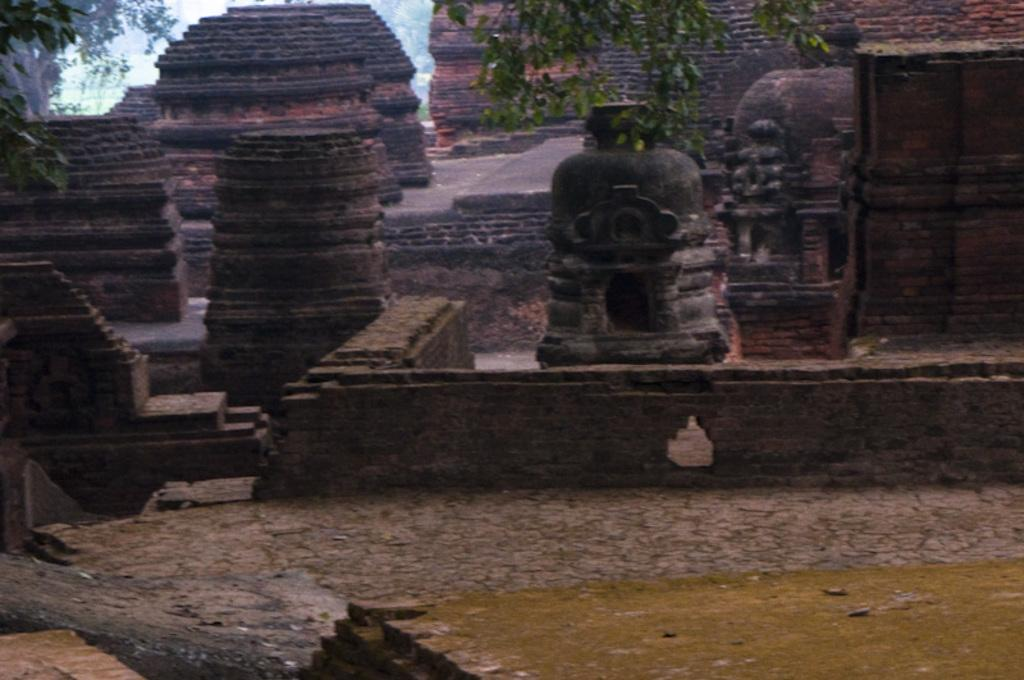What can be seen at the bottom of the image? The ground is visible in the image. What type of artwork is present in the image? There are stone sculptures in the image. What type of natural environment is visible in the background of the image? There are trees in the background of the image. What type of business is being conducted in the image? There is no indication of any business activity in the image; it primarily features stone sculptures and trees. Can you see a stream flowing through the image? There is no stream visible in the image. 